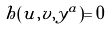<formula> <loc_0><loc_0><loc_500><loc_500>h ( u , v , y ^ { a } ) = 0</formula> 